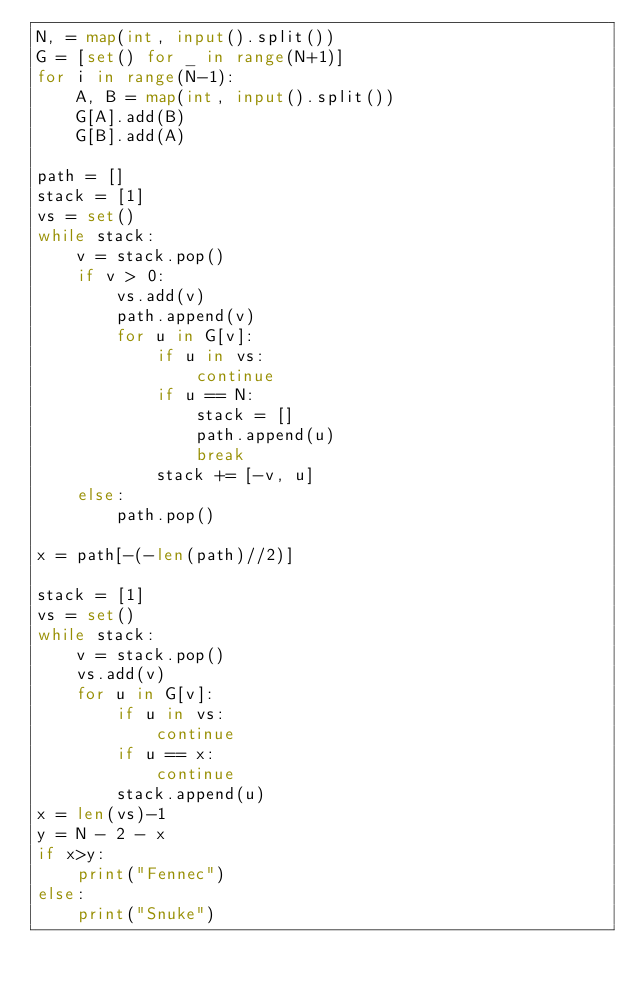Convert code to text. <code><loc_0><loc_0><loc_500><loc_500><_Python_>N, = map(int, input().split())
G = [set() for _ in range(N+1)]
for i in range(N-1):
    A, B = map(int, input().split())
    G[A].add(B)
    G[B].add(A)

path = []
stack = [1]
vs = set()
while stack:
    v = stack.pop()
    if v > 0:
        vs.add(v)
        path.append(v)
        for u in G[v]:
            if u in vs:
                continue
            if u == N:
                stack = []
                path.append(u)
                break
            stack += [-v, u]
    else:
        path.pop()

x = path[-(-len(path)//2)]

stack = [1]
vs = set()
while stack:
    v = stack.pop()
    vs.add(v)
    for u in G[v]:
        if u in vs:
            continue
        if u == x:
            continue
        stack.append(u)
x = len(vs)-1
y = N - 2 - x
if x>y:
    print("Fennec")
else:
    print("Snuke")
</code> 